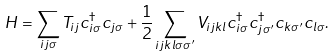<formula> <loc_0><loc_0><loc_500><loc_500>H = \sum _ { i j \sigma } T _ { i j } c ^ { \dagger } _ { i \sigma } c _ { j \sigma } + \frac { 1 } { 2 } \sum _ { i j k l \sigma \sigma ^ { \prime } } V _ { i j k l } c ^ { \dagger } _ { i \sigma } c ^ { \dagger } _ { j \sigma ^ { \prime } } c _ { k \sigma ^ { \prime } } c _ { l \sigma } .</formula> 